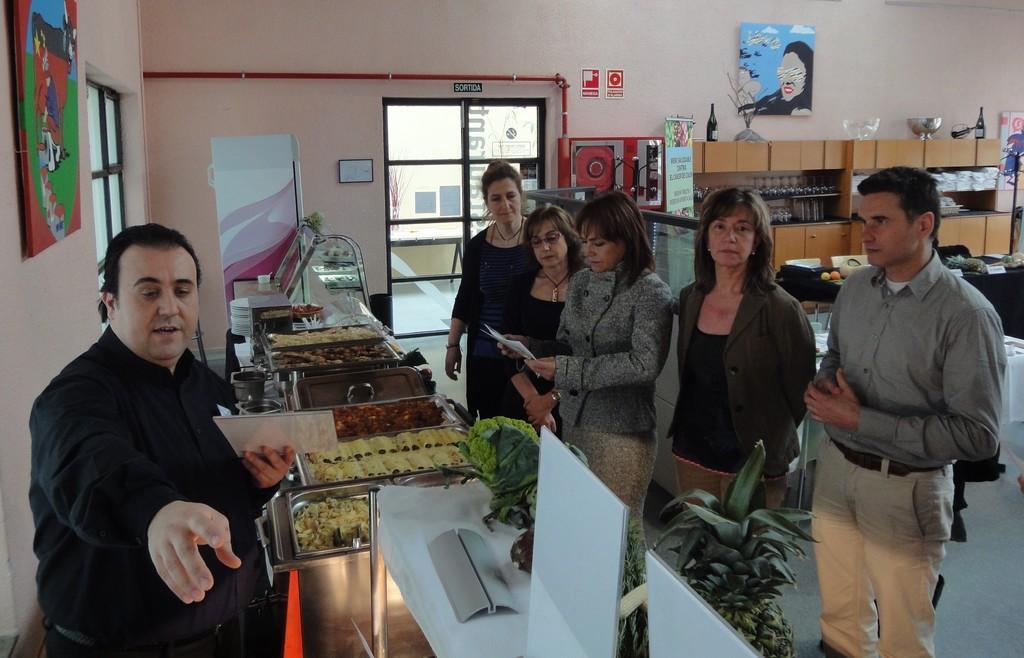Can you describe this image briefly? In this picture, we see a man in black shirt is sitting on the chair. He is holding a white card in his hand. In front of him, we see the vessels containing many food items. Beside that, we see a white table. Beside that, we see the flower pots. Here, we see four women and a man ares standing. The woman in the middle is holding a paper in her hands. Behind them, we see a table on which some objects are placed. Beside that, we see a rack in which glasses, bowls, tissue papers, glass bottles and flower vases are placed. Beside that, we see a board with some text written on it. In the background, we see a glass door and a wall on which poster is pasted. On the left side, we see a poster is pasted on the wall. 